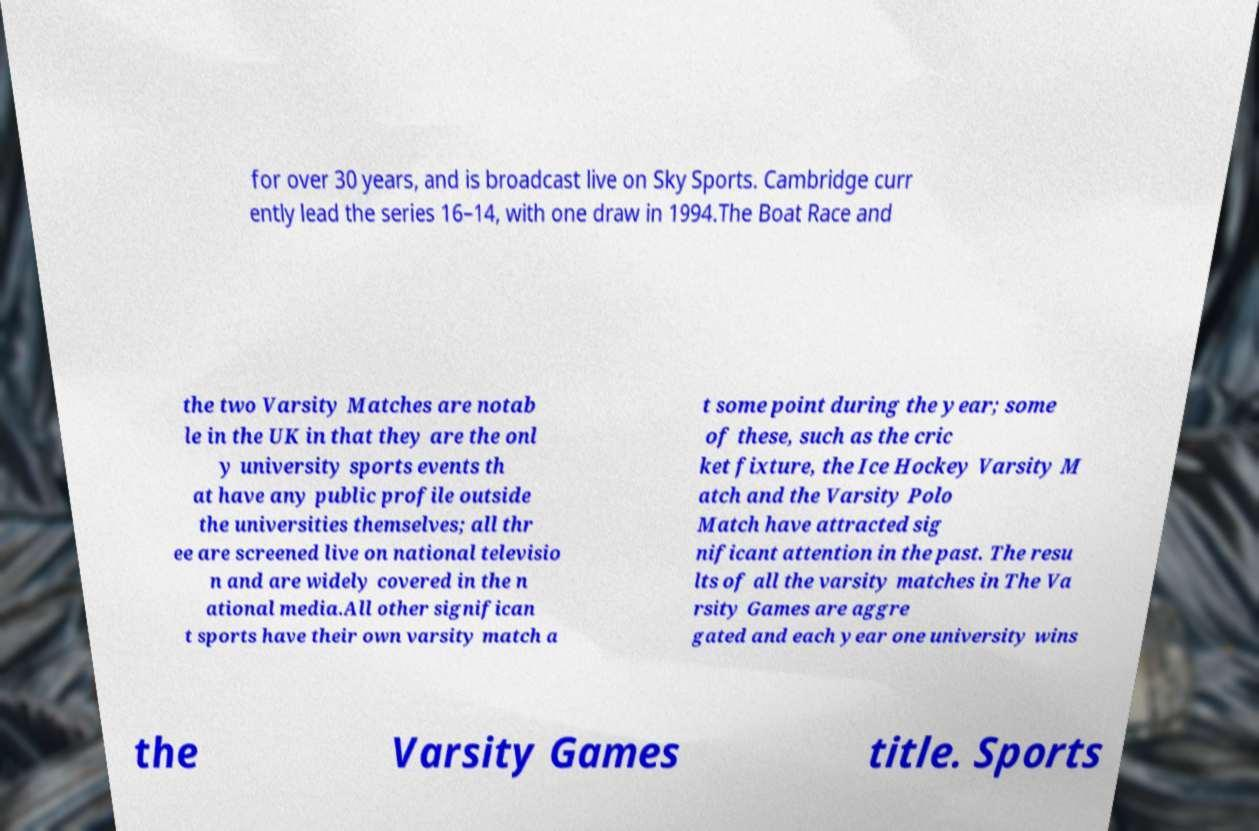I need the written content from this picture converted into text. Can you do that? for over 30 years, and is broadcast live on Sky Sports. Cambridge curr ently lead the series 16–14, with one draw in 1994.The Boat Race and the two Varsity Matches are notab le in the UK in that they are the onl y university sports events th at have any public profile outside the universities themselves; all thr ee are screened live on national televisio n and are widely covered in the n ational media.All other significan t sports have their own varsity match a t some point during the year; some of these, such as the cric ket fixture, the Ice Hockey Varsity M atch and the Varsity Polo Match have attracted sig nificant attention in the past. The resu lts of all the varsity matches in The Va rsity Games are aggre gated and each year one university wins the Varsity Games title. Sports 